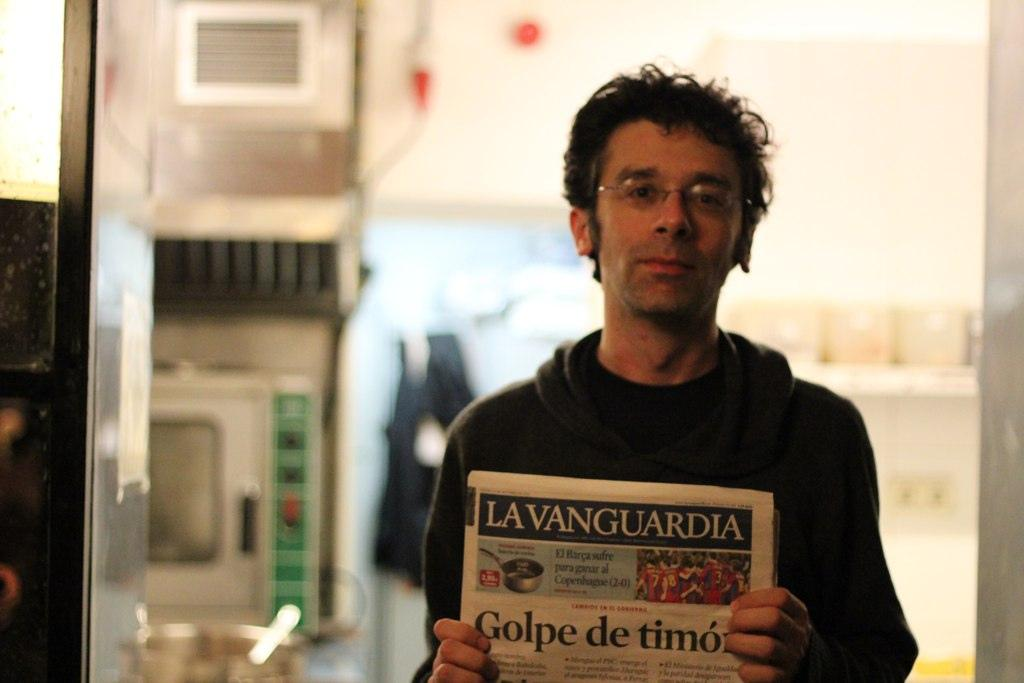Who is present in the image? There is a man in the image. What is the man holding in the image? The man is holding papers. Can you describe the background of the image? The background of the man is blurred. What type of cheese can be seen in the image? There is no cheese present in the image. How does the man stretch in the image? The man is not stretching in the image; he is holding papers. 